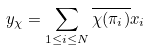Convert formula to latex. <formula><loc_0><loc_0><loc_500><loc_500>y _ { \chi } = \sum _ { 1 \leq i \leq N } \overline { \chi ( \pi _ { i } ) } x _ { i }</formula> 